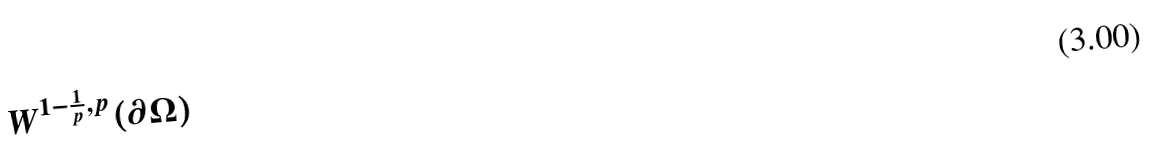<formula> <loc_0><loc_0><loc_500><loc_500>W ^ { 1 - \frac { 1 } { p } , p } ( \partial \Omega )</formula> 